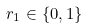Convert formula to latex. <formula><loc_0><loc_0><loc_500><loc_500>r _ { 1 } \in \{ 0 , 1 \}</formula> 